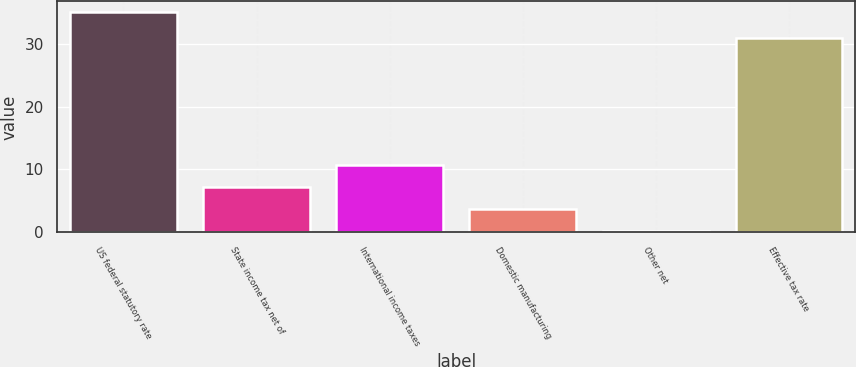Convert chart to OTSL. <chart><loc_0><loc_0><loc_500><loc_500><bar_chart><fcel>US federal statutory rate<fcel>State income tax net of<fcel>International income taxes<fcel>Domestic manufacturing<fcel>Other net<fcel>Effective tax rate<nl><fcel>35<fcel>7.16<fcel>10.64<fcel>3.68<fcel>0.2<fcel>31<nl></chart> 